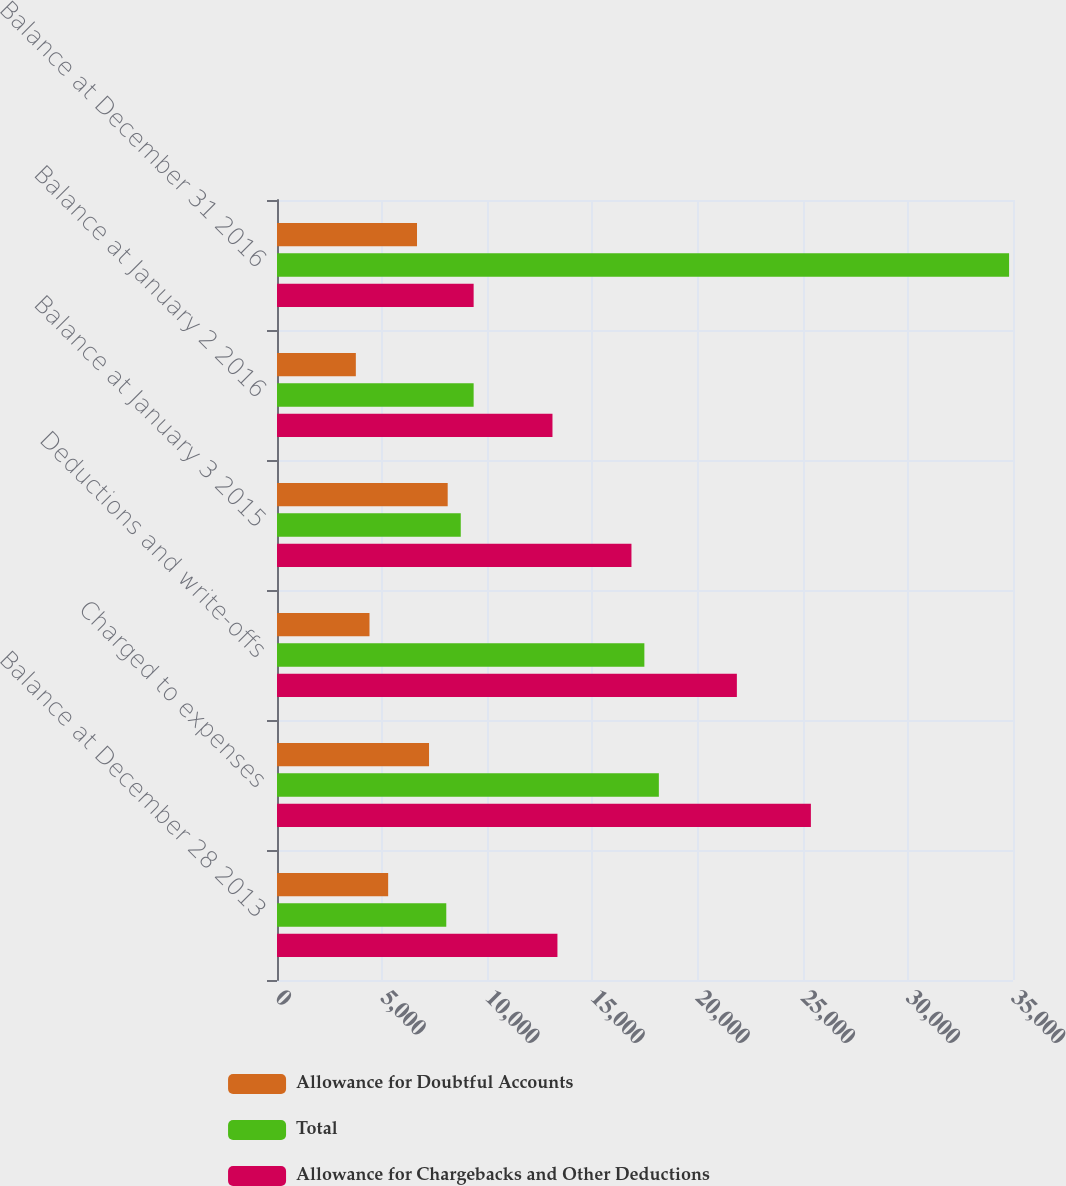Convert chart. <chart><loc_0><loc_0><loc_500><loc_500><stacked_bar_chart><ecel><fcel>Balance at December 28 2013<fcel>Charged to expenses<fcel>Deductions and write-offs<fcel>Balance at January 3 2015<fcel>Balance at January 2 2016<fcel>Balance at December 31 2016<nl><fcel>Allowance for Doubtful Accounts<fcel>5286<fcel>7230<fcel>4399<fcel>8117<fcel>3749<fcel>6658<nl><fcel>Total<fcel>8050<fcel>18159<fcel>17470<fcel>8739<fcel>9351<fcel>34814<nl><fcel>Allowance for Chargebacks and Other Deductions<fcel>13336<fcel>25389<fcel>21869<fcel>16856<fcel>13100<fcel>9351<nl></chart> 